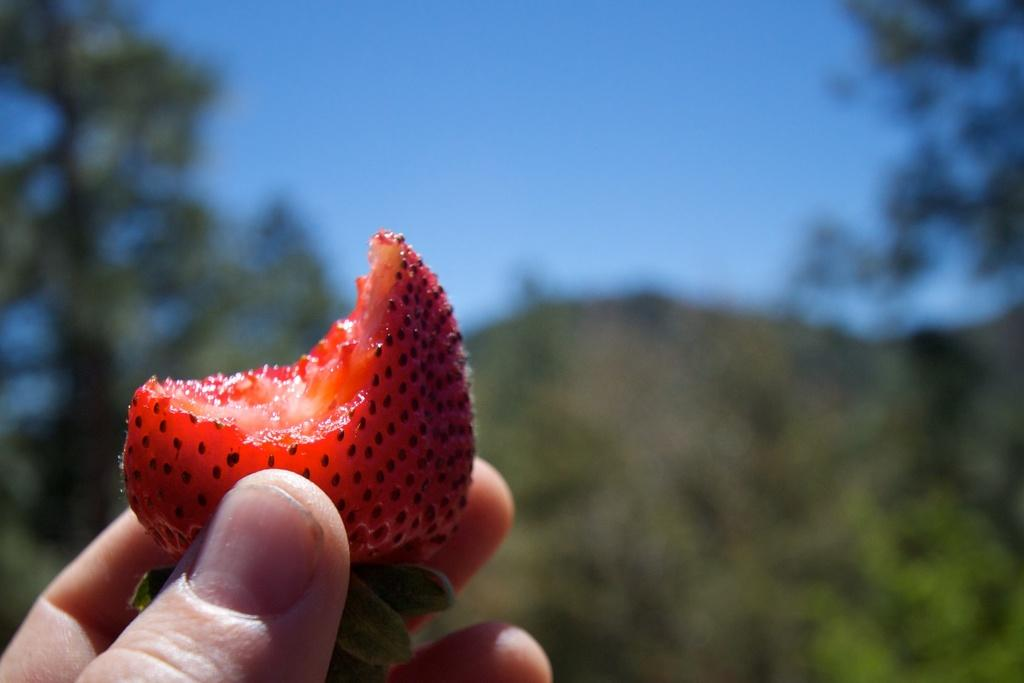What is the main subject of the image? The main subject of the image is a half-eaten strawberry. How is the strawberry being held in the image? The strawberry is held by a person's hand in the image. What can be seen in the background of the image? There are trees and a clear sky visible in the background of the image. What type of glue is being used to answer the question about the loss in the image? There is no glue, question about loss, or answer present in the image. 